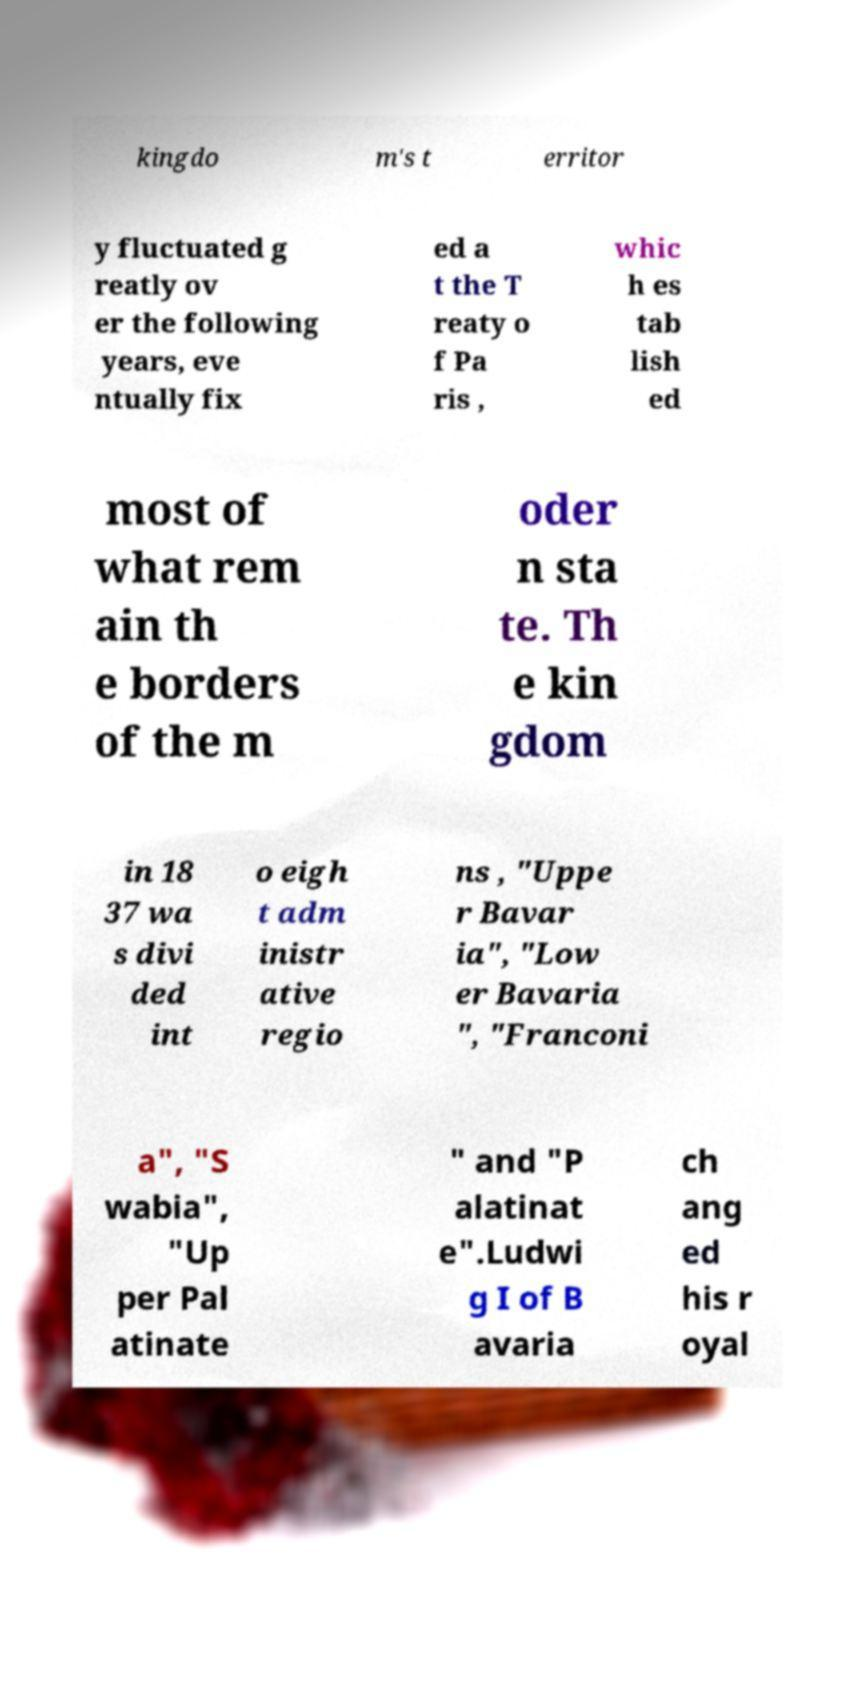Can you accurately transcribe the text from the provided image for me? kingdo m's t erritor y fluctuated g reatly ov er the following years, eve ntually fix ed a t the T reaty o f Pa ris , whic h es tab lish ed most of what rem ain th e borders of the m oder n sta te. Th e kin gdom in 18 37 wa s divi ded int o eigh t adm inistr ative regio ns , "Uppe r Bavar ia", "Low er Bavaria ", "Franconi a", "S wabia", "Up per Pal atinate " and "P alatinat e".Ludwi g I of B avaria ch ang ed his r oyal 